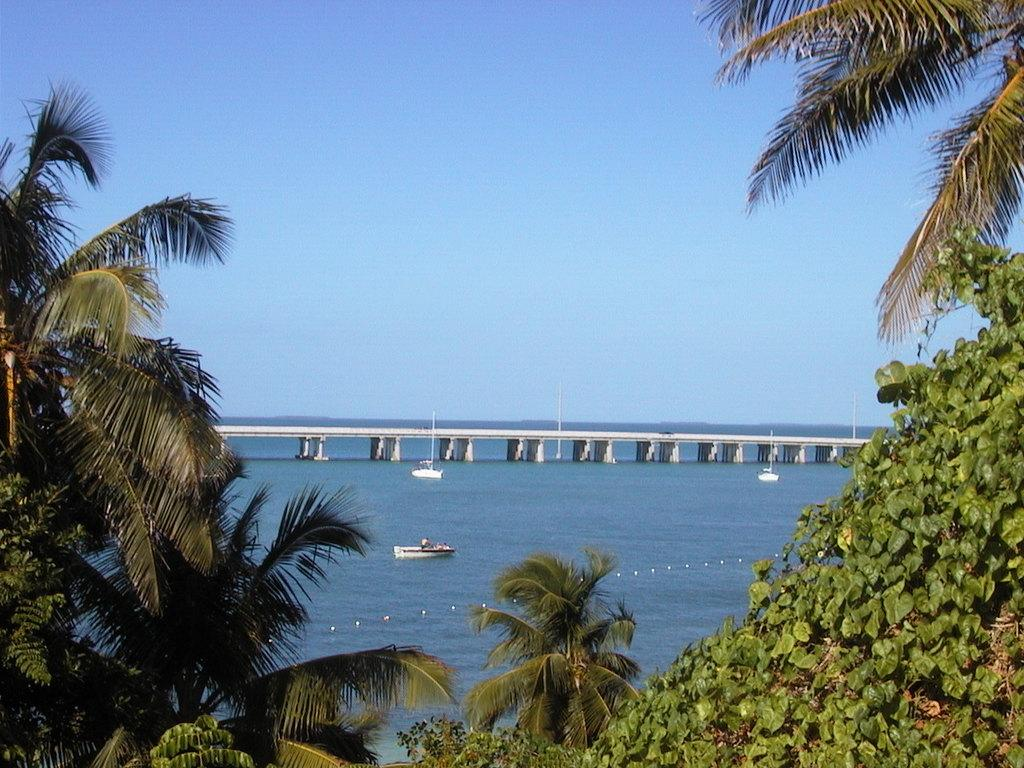What type of vegetation is at the bottom of the image? There are trees at the bottom of the image. What can be seen floating on the water in the image? There are boats visible in the image. What structure connects the two sides of the water in the image? There is a bridge in the image. What is the primary body of water in the image? The surface of water is present in the image. What is visible in the background of the image? The sky is visible in the background of the image. Where is the stage located in the image? There is no stage present in the image. What type of magic is being performed on the bridge in the image? There is no magic or performance taking place in the image; it simply shows a bridge, boats, and trees. 